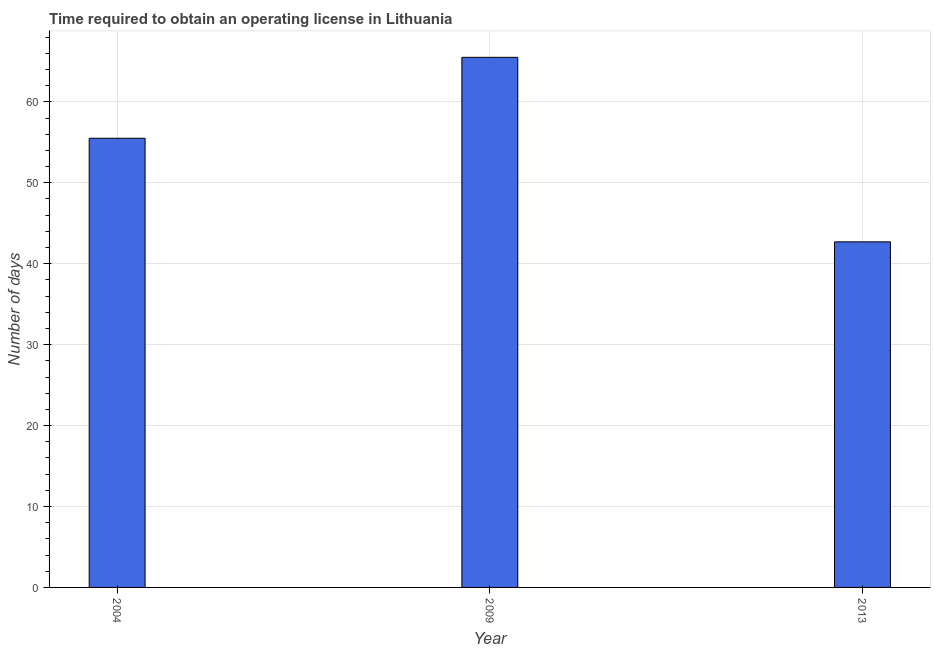What is the title of the graph?
Your response must be concise. Time required to obtain an operating license in Lithuania. What is the label or title of the X-axis?
Ensure brevity in your answer.  Year. What is the label or title of the Y-axis?
Your answer should be compact. Number of days. What is the number of days to obtain operating license in 2009?
Provide a succinct answer. 65.5. Across all years, what is the maximum number of days to obtain operating license?
Offer a terse response. 65.5. Across all years, what is the minimum number of days to obtain operating license?
Your answer should be compact. 42.7. What is the sum of the number of days to obtain operating license?
Offer a terse response. 163.7. What is the difference between the number of days to obtain operating license in 2004 and 2009?
Make the answer very short. -10. What is the average number of days to obtain operating license per year?
Offer a terse response. 54.57. What is the median number of days to obtain operating license?
Provide a short and direct response. 55.5. In how many years, is the number of days to obtain operating license greater than 42 days?
Give a very brief answer. 3. Do a majority of the years between 2013 and 2004 (inclusive) have number of days to obtain operating license greater than 14 days?
Provide a short and direct response. Yes. Is the number of days to obtain operating license in 2004 less than that in 2013?
Keep it short and to the point. No. What is the difference between the highest and the lowest number of days to obtain operating license?
Make the answer very short. 22.8. In how many years, is the number of days to obtain operating license greater than the average number of days to obtain operating license taken over all years?
Provide a succinct answer. 2. How many bars are there?
Your response must be concise. 3. Are all the bars in the graph horizontal?
Offer a very short reply. No. How many years are there in the graph?
Ensure brevity in your answer.  3. What is the difference between two consecutive major ticks on the Y-axis?
Keep it short and to the point. 10. What is the Number of days in 2004?
Your answer should be compact. 55.5. What is the Number of days of 2009?
Give a very brief answer. 65.5. What is the Number of days of 2013?
Make the answer very short. 42.7. What is the difference between the Number of days in 2004 and 2009?
Keep it short and to the point. -10. What is the difference between the Number of days in 2009 and 2013?
Offer a very short reply. 22.8. What is the ratio of the Number of days in 2004 to that in 2009?
Your answer should be very brief. 0.85. What is the ratio of the Number of days in 2009 to that in 2013?
Provide a succinct answer. 1.53. 